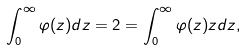Convert formula to latex. <formula><loc_0><loc_0><loc_500><loc_500>\int _ { 0 } ^ { \infty } \varphi ( z ) d z = 2 = \int _ { 0 } ^ { \infty } \varphi ( z ) z d z ,</formula> 